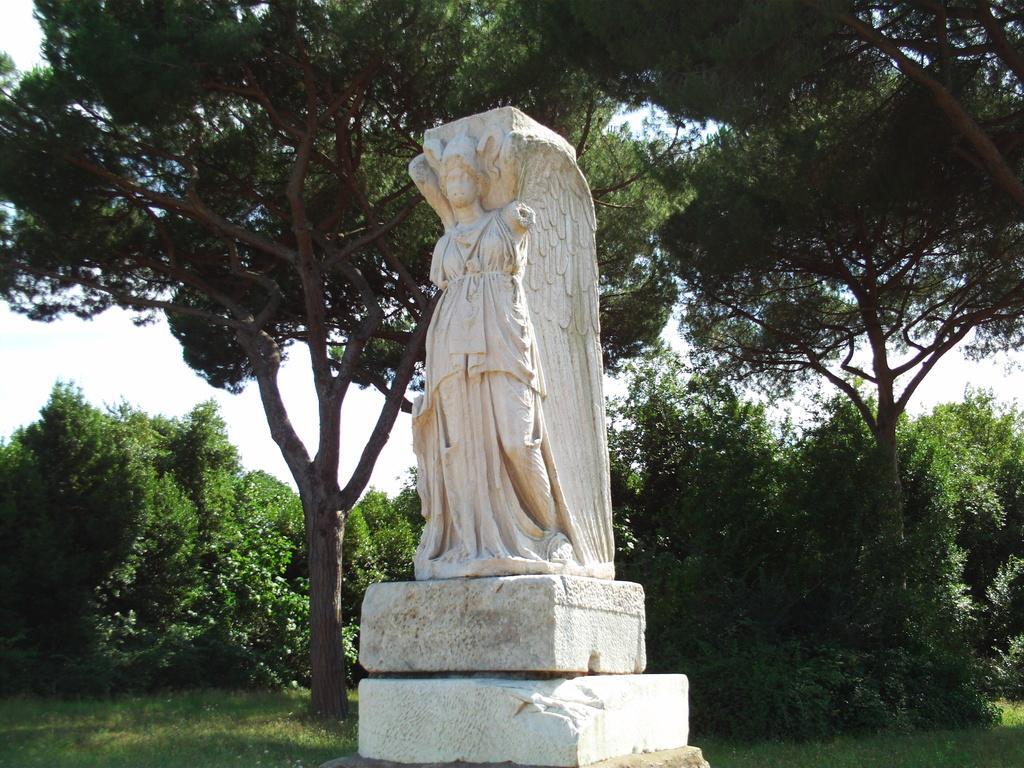Please provide a concise description of this image. In the middle of this image, there is a statue of a person on a platform. In the background, there are trees and grass on the ground and there are clouds in the sky. 